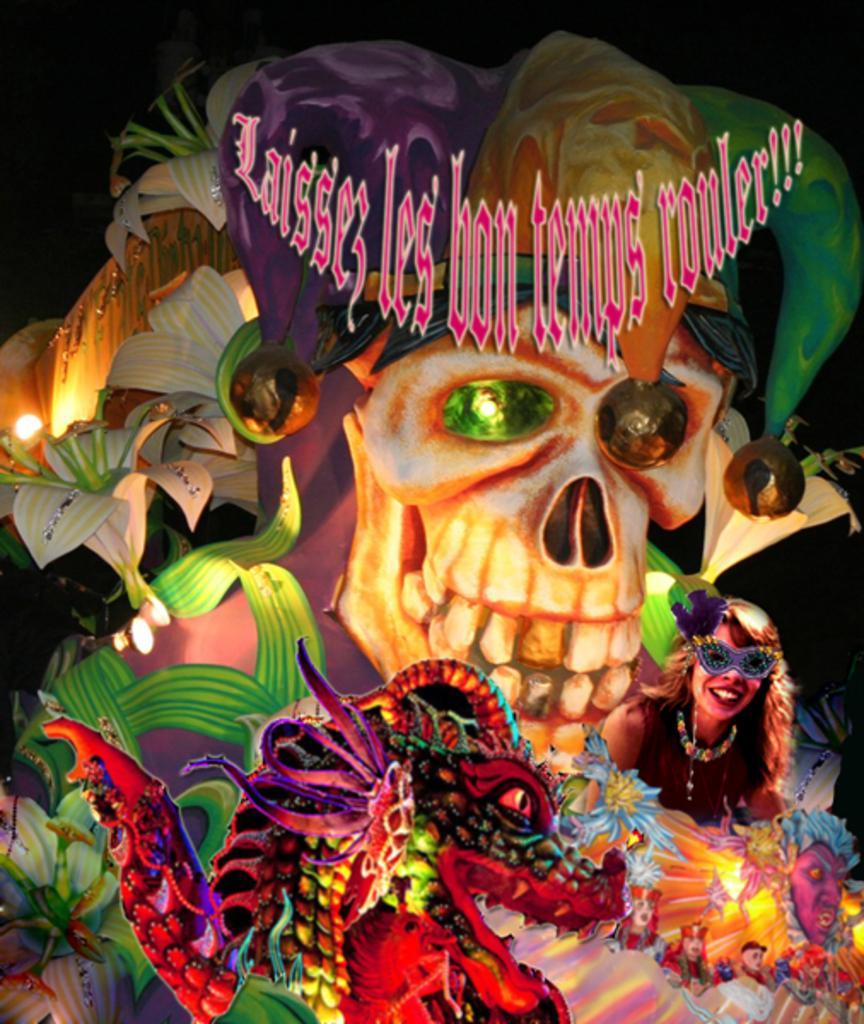In one or two sentences, can you explain what this image depicts? In this picture I can see a painting of costume and a skull. Here I can see a woman is wearing a mask and smiling. The background image is dark. Here I can see something written on it. 